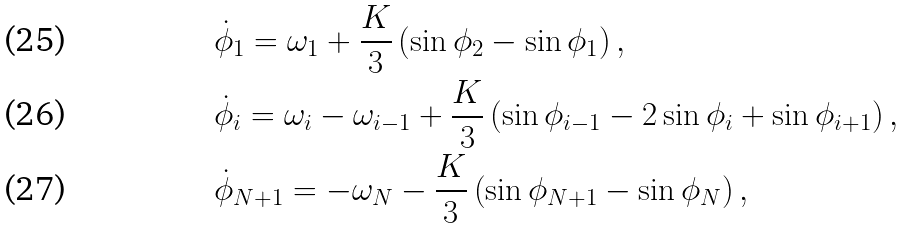Convert formula to latex. <formula><loc_0><loc_0><loc_500><loc_500>& \dot { \phi } _ { 1 } = \omega _ { 1 } + \frac { K } { 3 } \left ( \sin \phi _ { 2 } - \sin \phi _ { 1 } \right ) , \\ & \dot { \phi } _ { i } = \omega _ { i } - \omega _ { i - 1 } + \frac { K } { 3 } \left ( \sin \phi _ { i - 1 } - 2 \sin \phi _ { i } + \sin \phi _ { i + 1 } \right ) , \\ & \dot { \phi } _ { N + 1 } = - \omega _ { N } - \frac { K } { 3 } \left ( \sin \phi _ { N + 1 } - \sin \phi _ { N } \right ) ,</formula> 